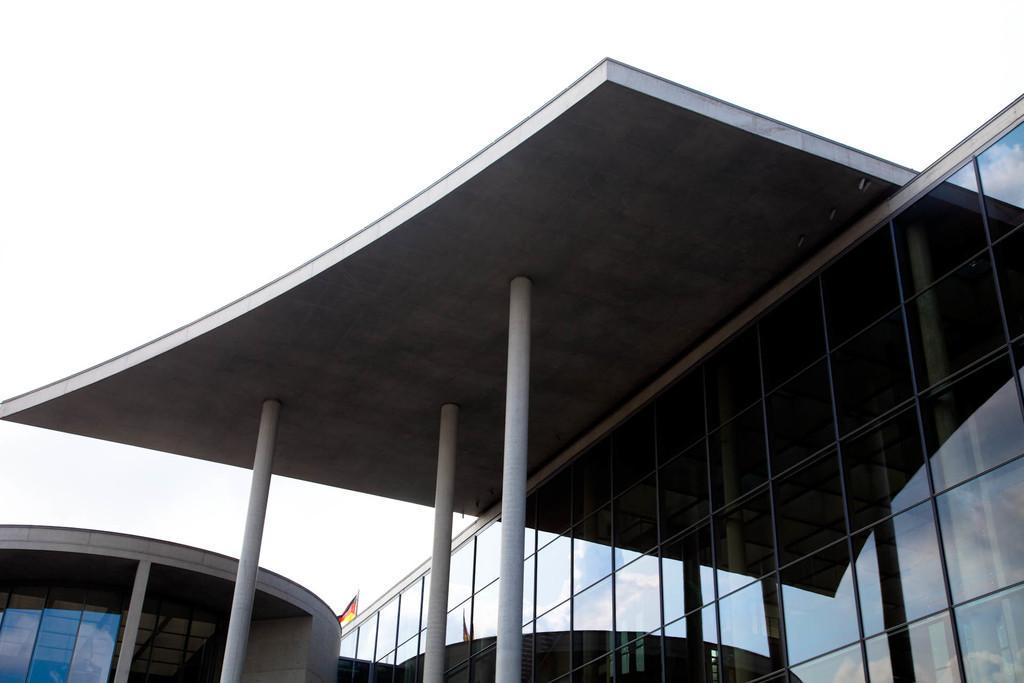In one or two sentences, can you explain what this image depicts? As we can see in the image there are buildings and at the top there is sky. 